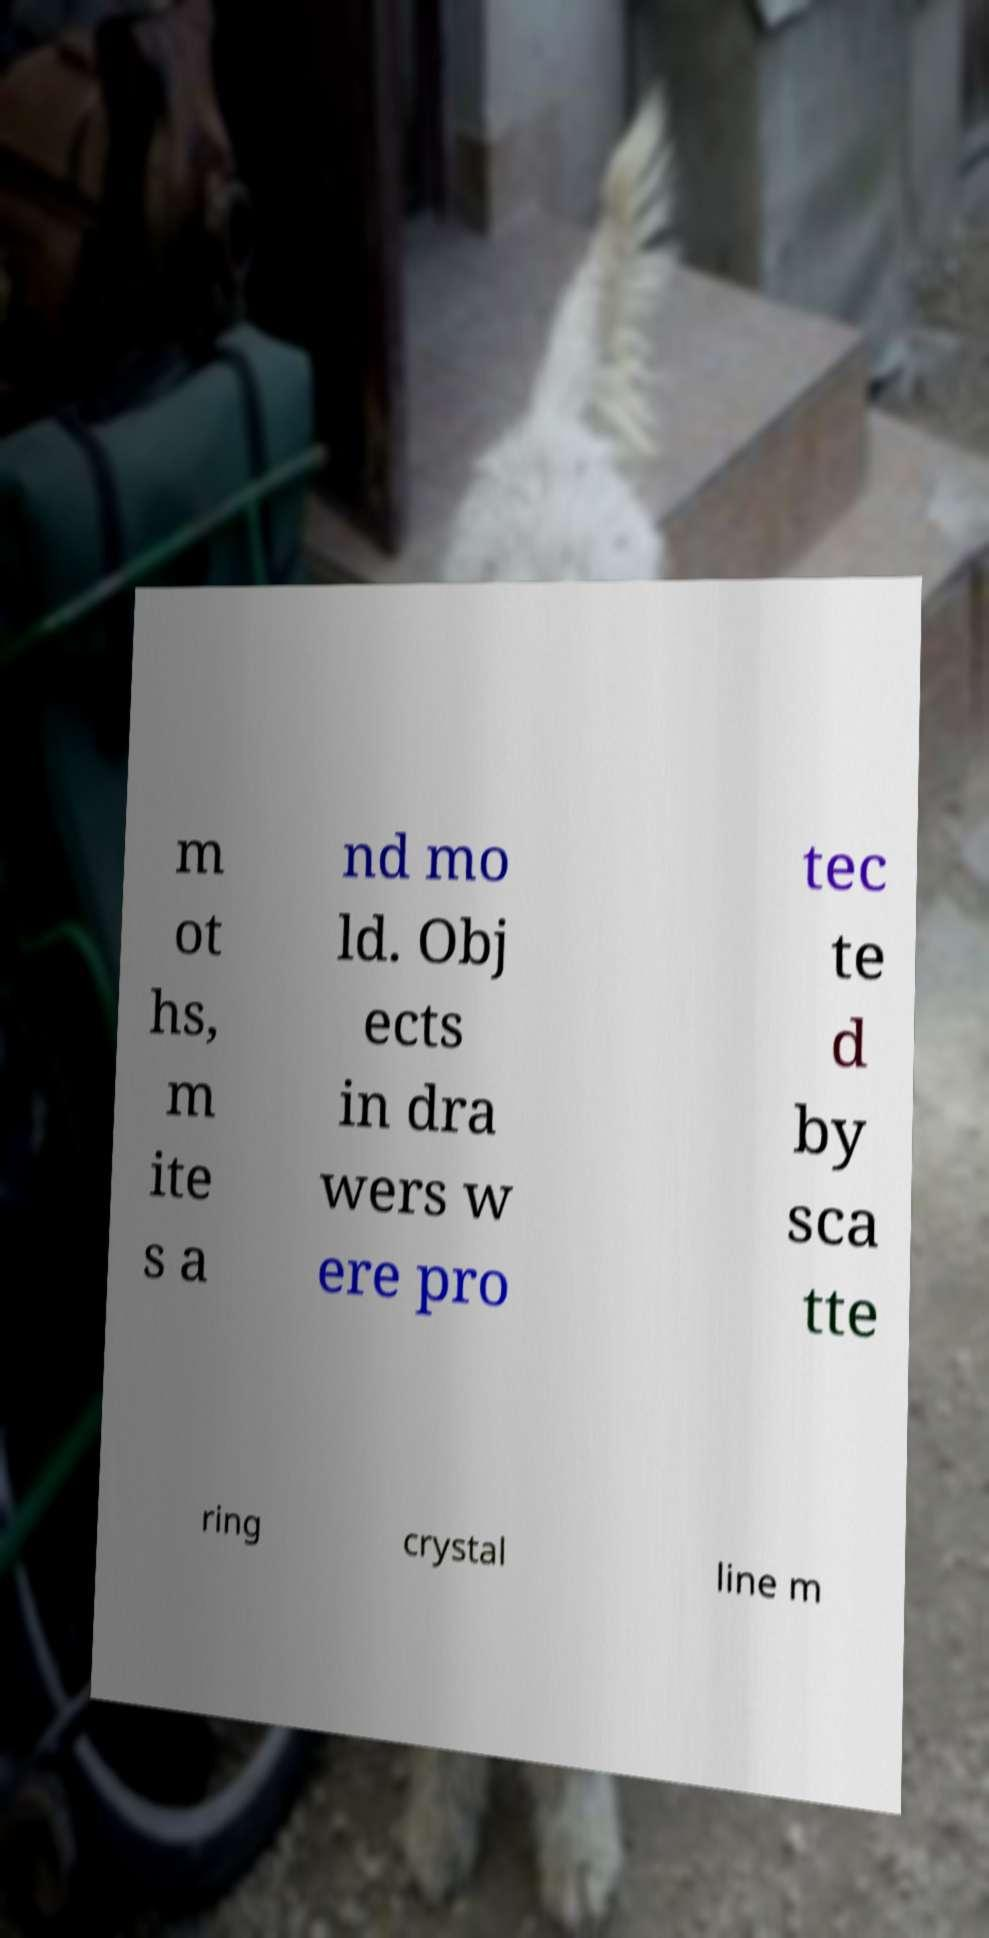What messages or text are displayed in this image? I need them in a readable, typed format. m ot hs, m ite s a nd mo ld. Obj ects in dra wers w ere pro tec te d by sca tte ring crystal line m 